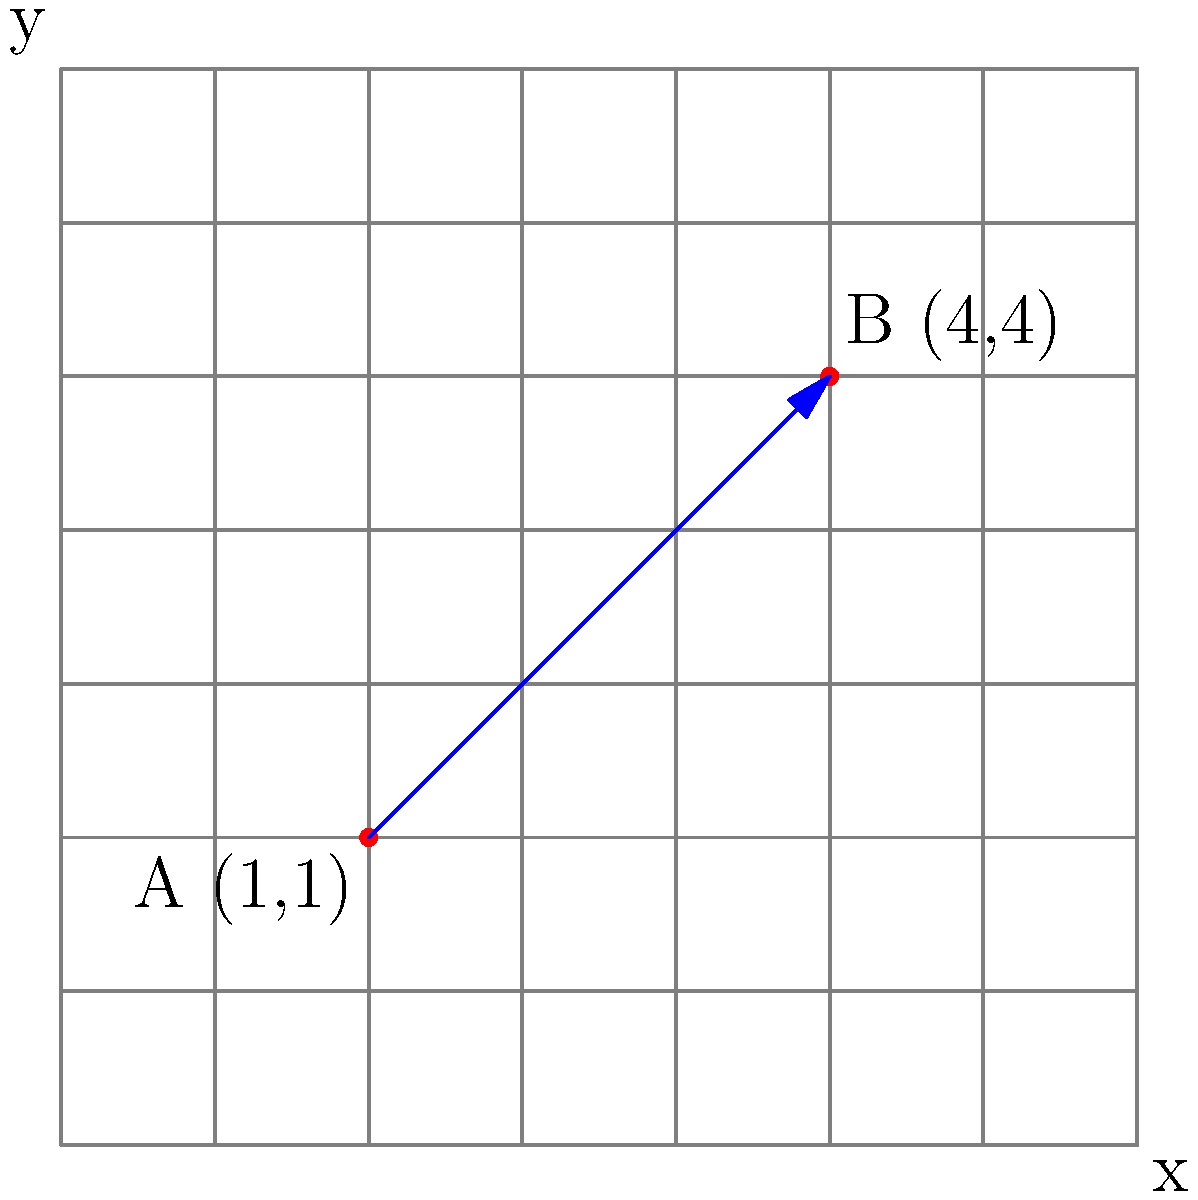In an open-pit mine layout, two drilling points A and B are located at coordinates (1,1) and (4,4) respectively on a grid where each unit represents 10 meters. Calculate the optimal distance between these drilling points to determine the spacing for the drilling pattern. To calculate the optimal distance between the two drilling points, we need to use the distance formula derived from the Pythagorean theorem:

1. The distance formula is: 
   $$d = \sqrt{(x_2 - x_1)^2 + (y_2 - y_1)^2}$$

2. We have the following coordinates:
   Point A: $(x_1, y_1) = (1, 1)$
   Point B: $(x_2, y_2) = (4, 4)$

3. Let's substitute these values into the formula:
   $$d = \sqrt{(4 - 1)^2 + (4 - 1)^2}$$

4. Simplify the expressions inside the parentheses:
   $$d = \sqrt{3^2 + 3^2}$$

5. Calculate the squares:
   $$d = \sqrt{9 + 9}$$

6. Add the values under the square root:
   $$d = \sqrt{18}$$

7. Simplify the square root:
   $$d = 3\sqrt{2}$$

8. Since each unit represents 10 meters, we multiply our result by 10:
   $$d = 30\sqrt{2} \approx 42.43\text{ meters}$$

Therefore, the optimal distance between the drilling points is $30\sqrt{2}$ meters or approximately 42.43 meters.
Answer: $30\sqrt{2}$ meters 